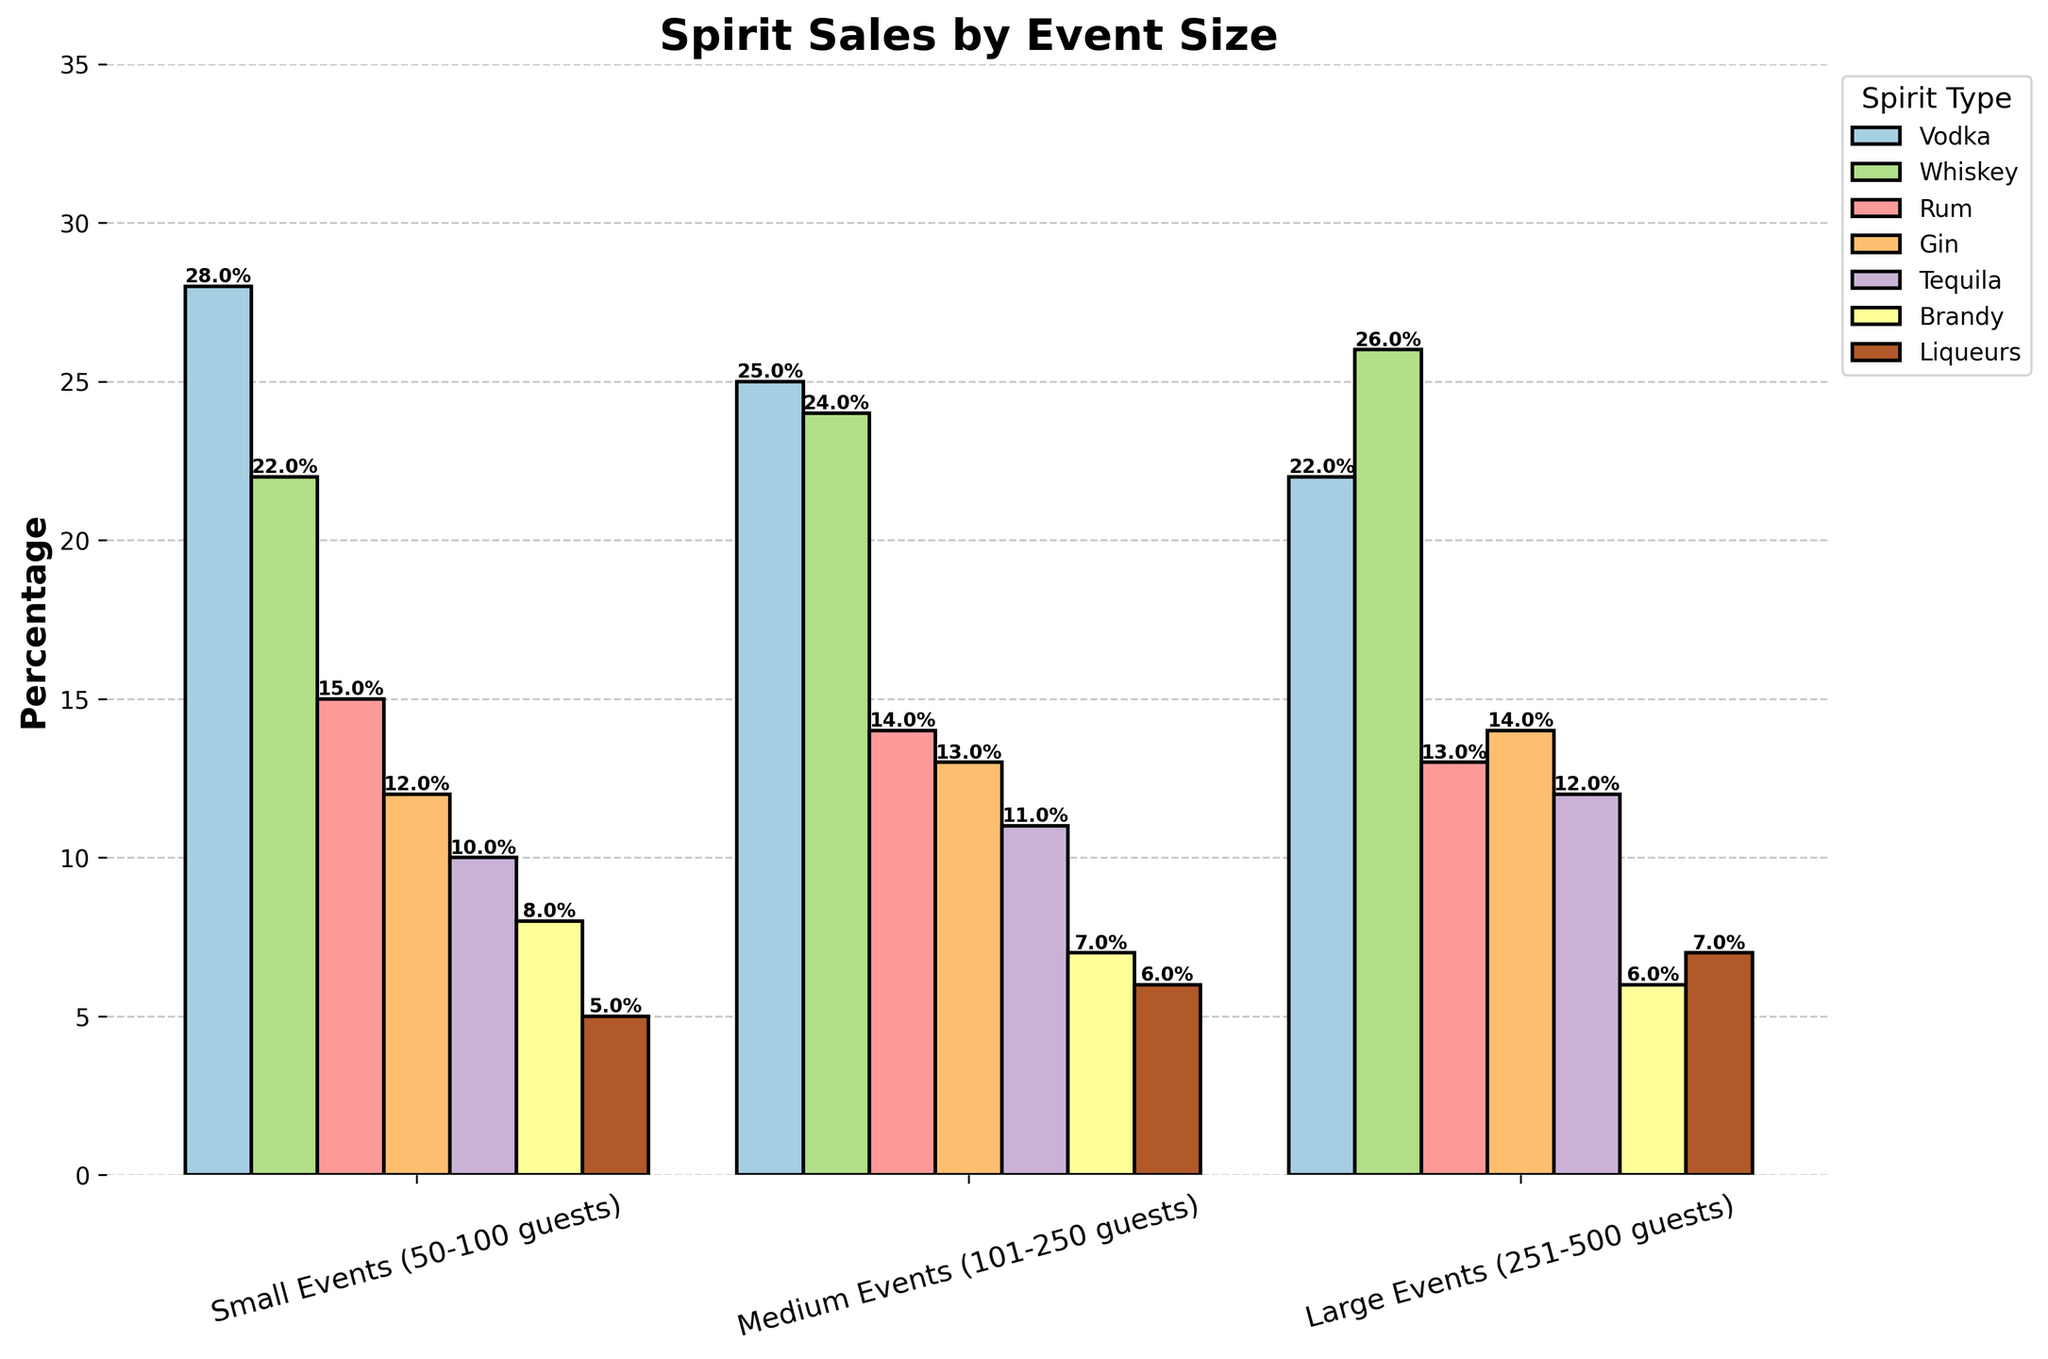Which spirit type has the highest sales percentage for small events? To find the highest sales percentage for small events, look at the bar heights in the "Small Events" category. The vodka bar is the tallest at 28%.
Answer: Vodka Which event size has the highest percentage of whiskey sales? Look at the whiskey bars across all event sizes. The highest bar is in the "Large Events" category at 26%.
Answer: Large Events What is the total sales percentage of gin across all event sizes? Sum the gin sales percentages: 12% (Small Events) + 13% (Medium Events) + 14% (Large Events) = 39%.
Answer: 39% How much higher is the percentage of tequila sales in large events compared to small events? Subtract the tequila percentage in small events from that in large events: 12% - 10% = 2%.
Answer: 2% Compare the sales percentage of rum between small and medium events. Which one is higher? Compare the rum bars in small and medium events. The small events have a higher percentage at 15% compared to 14% in medium events.
Answer: Small Events What is the average sales percentage of brandy across all event sizes? Calculate the average: (8% (Small Events) + 7% (Medium Events) + 6% (Large Events)) / 3 = 7%.
Answer: 7% Which spirit type shows an increase in sales percentage from small to large events? Compare the percentages for each spirit type from small to large events. Whiskey increases from 22% to 26%, and liqueurs increase from 5% to 7%.
Answer: Whiskey, Liqueurs How do sales percentages of liqueurs change with event size? Analyze the liqueurs bars across event sizes: 5% (Small Events), 6% (Medium Events), and 7% (Large Events). There is a steady increase.
Answer: Increase steadily What is the difference in the sales percentage of vodka between small events and large events? Subtract the vodka percentage in large events from that in small events: 28% - 22% = 6%.
Answer: 6% Which spirit type has the lowest sales percentage for medium events? Look at the heights of the bars in the "Medium Events" category. Brandy has the lowest at 7%.
Answer: Brandy 